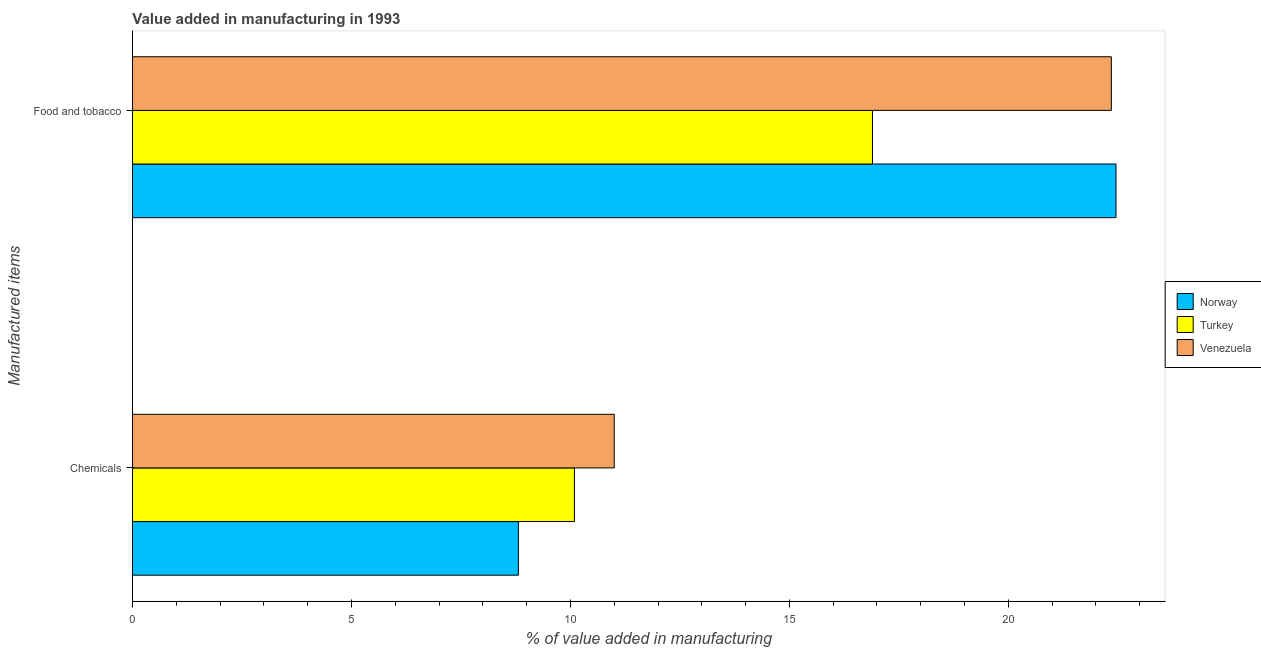How many groups of bars are there?
Ensure brevity in your answer.  2. Are the number of bars per tick equal to the number of legend labels?
Give a very brief answer. Yes. Are the number of bars on each tick of the Y-axis equal?
Your response must be concise. Yes. How many bars are there on the 2nd tick from the top?
Ensure brevity in your answer.  3. What is the label of the 1st group of bars from the top?
Offer a terse response. Food and tobacco. What is the value added by  manufacturing chemicals in Venezuela?
Make the answer very short. 11. Across all countries, what is the maximum value added by  manufacturing chemicals?
Offer a very short reply. 11. Across all countries, what is the minimum value added by  manufacturing chemicals?
Make the answer very short. 8.81. What is the total value added by  manufacturing chemicals in the graph?
Keep it short and to the point. 29.91. What is the difference between the value added by manufacturing food and tobacco in Venezuela and that in Norway?
Make the answer very short. -0.11. What is the difference between the value added by manufacturing food and tobacco in Venezuela and the value added by  manufacturing chemicals in Turkey?
Give a very brief answer. 12.26. What is the average value added by manufacturing food and tobacco per country?
Make the answer very short. 20.57. What is the difference between the value added by manufacturing food and tobacco and value added by  manufacturing chemicals in Norway?
Offer a very short reply. 13.64. In how many countries, is the value added by  manufacturing chemicals greater than 17 %?
Give a very brief answer. 0. What is the ratio of the value added by manufacturing food and tobacco in Turkey to that in Norway?
Provide a short and direct response. 0.75. Is the value added by  manufacturing chemicals in Turkey less than that in Venezuela?
Your answer should be very brief. Yes. In how many countries, is the value added by  manufacturing chemicals greater than the average value added by  manufacturing chemicals taken over all countries?
Provide a short and direct response. 2. What does the 1st bar from the top in Chemicals represents?
Offer a terse response. Venezuela. How many bars are there?
Your response must be concise. 6. Are the values on the major ticks of X-axis written in scientific E-notation?
Your answer should be very brief. No. Does the graph contain any zero values?
Your response must be concise. No. How are the legend labels stacked?
Keep it short and to the point. Vertical. What is the title of the graph?
Offer a terse response. Value added in manufacturing in 1993. Does "Kyrgyz Republic" appear as one of the legend labels in the graph?
Offer a terse response. No. What is the label or title of the X-axis?
Provide a succinct answer. % of value added in manufacturing. What is the label or title of the Y-axis?
Your response must be concise. Manufactured items. What is the % of value added in manufacturing in Norway in Chemicals?
Your response must be concise. 8.81. What is the % of value added in manufacturing in Turkey in Chemicals?
Make the answer very short. 10.09. What is the % of value added in manufacturing of Venezuela in Chemicals?
Your answer should be very brief. 11. What is the % of value added in manufacturing in Norway in Food and tobacco?
Offer a very short reply. 22.46. What is the % of value added in manufacturing in Turkey in Food and tobacco?
Your response must be concise. 16.9. What is the % of value added in manufacturing in Venezuela in Food and tobacco?
Your response must be concise. 22.35. Across all Manufactured items, what is the maximum % of value added in manufacturing of Norway?
Offer a terse response. 22.46. Across all Manufactured items, what is the maximum % of value added in manufacturing of Turkey?
Your answer should be compact. 16.9. Across all Manufactured items, what is the maximum % of value added in manufacturing of Venezuela?
Make the answer very short. 22.35. Across all Manufactured items, what is the minimum % of value added in manufacturing in Norway?
Keep it short and to the point. 8.81. Across all Manufactured items, what is the minimum % of value added in manufacturing in Turkey?
Give a very brief answer. 10.09. Across all Manufactured items, what is the minimum % of value added in manufacturing in Venezuela?
Ensure brevity in your answer.  11. What is the total % of value added in manufacturing in Norway in the graph?
Give a very brief answer. 31.27. What is the total % of value added in manufacturing of Turkey in the graph?
Keep it short and to the point. 26.99. What is the total % of value added in manufacturing of Venezuela in the graph?
Your response must be concise. 33.35. What is the difference between the % of value added in manufacturing of Norway in Chemicals and that in Food and tobacco?
Offer a terse response. -13.64. What is the difference between the % of value added in manufacturing in Turkey in Chemicals and that in Food and tobacco?
Offer a very short reply. -6.8. What is the difference between the % of value added in manufacturing in Venezuela in Chemicals and that in Food and tobacco?
Ensure brevity in your answer.  -11.35. What is the difference between the % of value added in manufacturing in Norway in Chemicals and the % of value added in manufacturing in Turkey in Food and tobacco?
Provide a succinct answer. -8.08. What is the difference between the % of value added in manufacturing in Norway in Chemicals and the % of value added in manufacturing in Venezuela in Food and tobacco?
Give a very brief answer. -13.54. What is the difference between the % of value added in manufacturing in Turkey in Chemicals and the % of value added in manufacturing in Venezuela in Food and tobacco?
Your answer should be compact. -12.26. What is the average % of value added in manufacturing in Norway per Manufactured items?
Keep it short and to the point. 15.63. What is the average % of value added in manufacturing in Turkey per Manufactured items?
Ensure brevity in your answer.  13.49. What is the average % of value added in manufacturing of Venezuela per Manufactured items?
Provide a succinct answer. 16.68. What is the difference between the % of value added in manufacturing of Norway and % of value added in manufacturing of Turkey in Chemicals?
Offer a terse response. -1.28. What is the difference between the % of value added in manufacturing in Norway and % of value added in manufacturing in Venezuela in Chemicals?
Your answer should be compact. -2.19. What is the difference between the % of value added in manufacturing in Turkey and % of value added in manufacturing in Venezuela in Chemicals?
Your answer should be very brief. -0.91. What is the difference between the % of value added in manufacturing in Norway and % of value added in manufacturing in Turkey in Food and tobacco?
Offer a very short reply. 5.56. What is the difference between the % of value added in manufacturing of Norway and % of value added in manufacturing of Venezuela in Food and tobacco?
Your answer should be very brief. 0.11. What is the difference between the % of value added in manufacturing of Turkey and % of value added in manufacturing of Venezuela in Food and tobacco?
Give a very brief answer. -5.45. What is the ratio of the % of value added in manufacturing in Norway in Chemicals to that in Food and tobacco?
Make the answer very short. 0.39. What is the ratio of the % of value added in manufacturing of Turkey in Chemicals to that in Food and tobacco?
Make the answer very short. 0.6. What is the ratio of the % of value added in manufacturing in Venezuela in Chemicals to that in Food and tobacco?
Keep it short and to the point. 0.49. What is the difference between the highest and the second highest % of value added in manufacturing in Norway?
Provide a short and direct response. 13.64. What is the difference between the highest and the second highest % of value added in manufacturing of Turkey?
Give a very brief answer. 6.8. What is the difference between the highest and the second highest % of value added in manufacturing in Venezuela?
Your response must be concise. 11.35. What is the difference between the highest and the lowest % of value added in manufacturing of Norway?
Provide a succinct answer. 13.64. What is the difference between the highest and the lowest % of value added in manufacturing of Turkey?
Offer a terse response. 6.8. What is the difference between the highest and the lowest % of value added in manufacturing in Venezuela?
Keep it short and to the point. 11.35. 